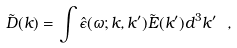<formula> <loc_0><loc_0><loc_500><loc_500>\tilde { D } ( { k } ) = \int \hat { \epsilon } ( \omega ; { k } , { k } ^ { \prime } ) \tilde { E } ( { k } ^ { \prime } ) d ^ { 3 } k ^ { \prime } \ ,</formula> 